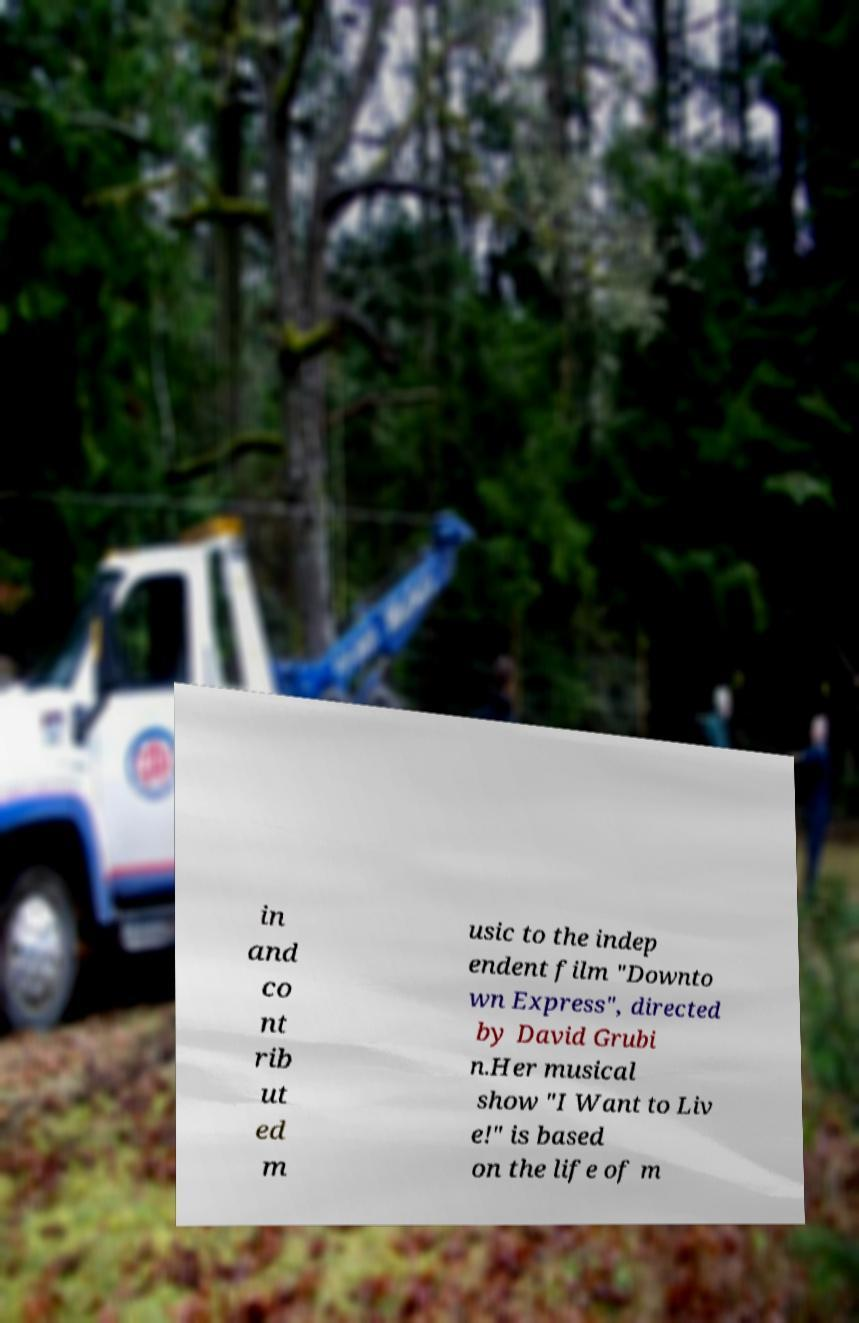For documentation purposes, I need the text within this image transcribed. Could you provide that? in and co nt rib ut ed m usic to the indep endent film "Downto wn Express", directed by David Grubi n.Her musical show "I Want to Liv e!" is based on the life of m 